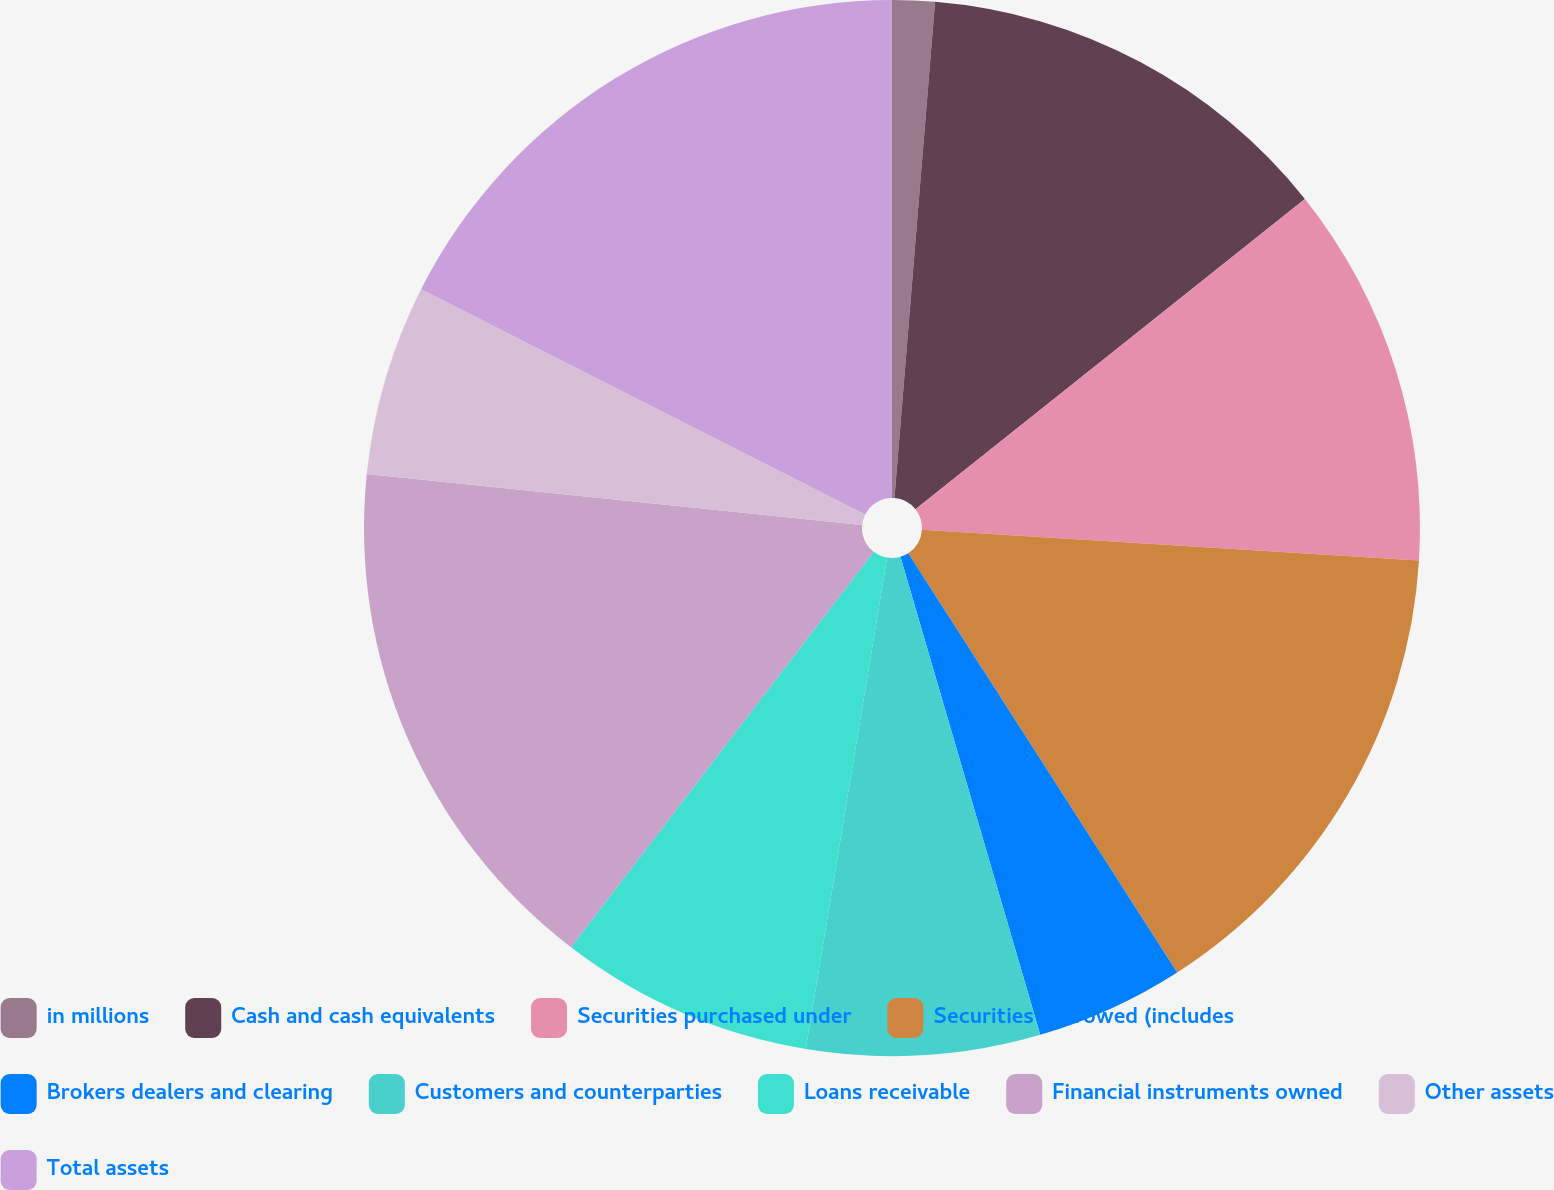<chart> <loc_0><loc_0><loc_500><loc_500><pie_chart><fcel>in millions<fcel>Cash and cash equivalents<fcel>Securities purchased under<fcel>Securities borrowed (includes<fcel>Brokers dealers and clearing<fcel>Customers and counterparties<fcel>Loans receivable<fcel>Financial instruments owned<fcel>Other assets<fcel>Total assets<nl><fcel>1.3%<fcel>12.99%<fcel>11.69%<fcel>14.94%<fcel>4.55%<fcel>7.14%<fcel>7.79%<fcel>16.23%<fcel>5.84%<fcel>17.53%<nl></chart> 